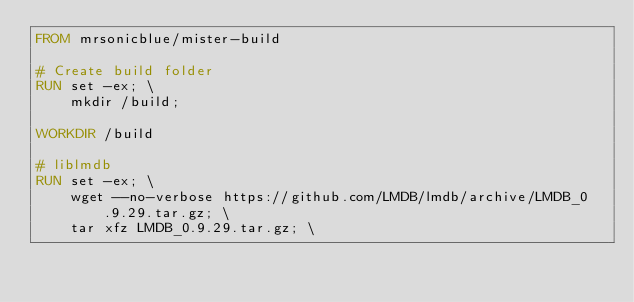<code> <loc_0><loc_0><loc_500><loc_500><_Dockerfile_>FROM mrsonicblue/mister-build

# Create build folder
RUN set -ex; \
    mkdir /build;

WORKDIR /build

# liblmdb
RUN set -ex; \
    wget --no-verbose https://github.com/LMDB/lmdb/archive/LMDB_0.9.29.tar.gz; \
    tar xfz LMDB_0.9.29.tar.gz; \</code> 